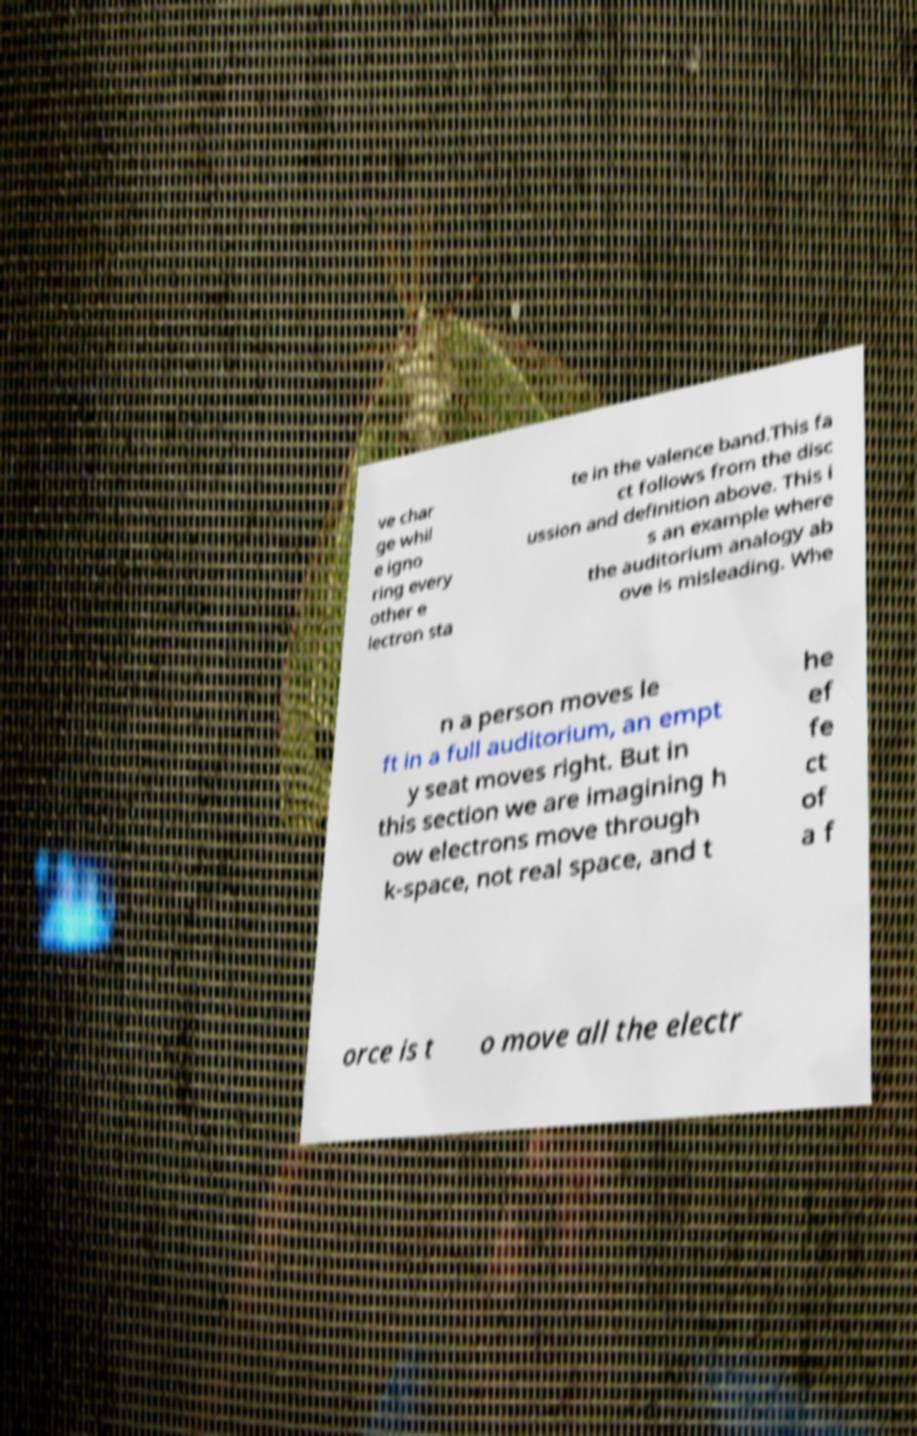I need the written content from this picture converted into text. Can you do that? ve char ge whil e igno ring every other e lectron sta te in the valence band.This fa ct follows from the disc ussion and definition above. This i s an example where the auditorium analogy ab ove is misleading. Whe n a person moves le ft in a full auditorium, an empt y seat moves right. But in this section we are imagining h ow electrons move through k-space, not real space, and t he ef fe ct of a f orce is t o move all the electr 